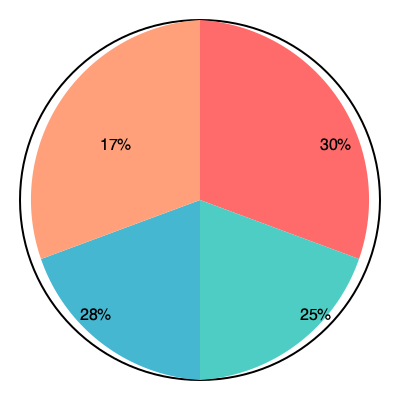Based on the pie chart showing the market share of women's soccer merchandise, what percentage of the market is not captured by the top three largest segments combined? To solve this problem, we need to follow these steps:

1. Identify the three largest segments in the pie chart:
   - 30% (red)
   - 28% (blue)
   - 25% (green)

2. Calculate the sum of these three largest segments:
   $30\% + 28\% + 25\% = 83\%$

3. The total market share is always 100%, so to find the percentage not captured by the top three segments, we subtract their sum from 100%:
   $100\% - 83\% = 17\%$

This 17% corresponds to the orange segment in the pie chart, which represents the market share not captured by the top three largest segments.
Answer: 17% 